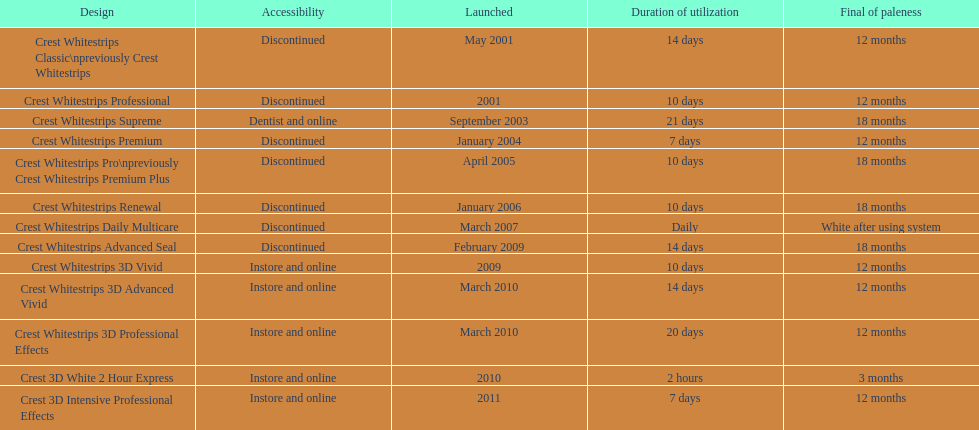Is each white strip discontinued? No. 